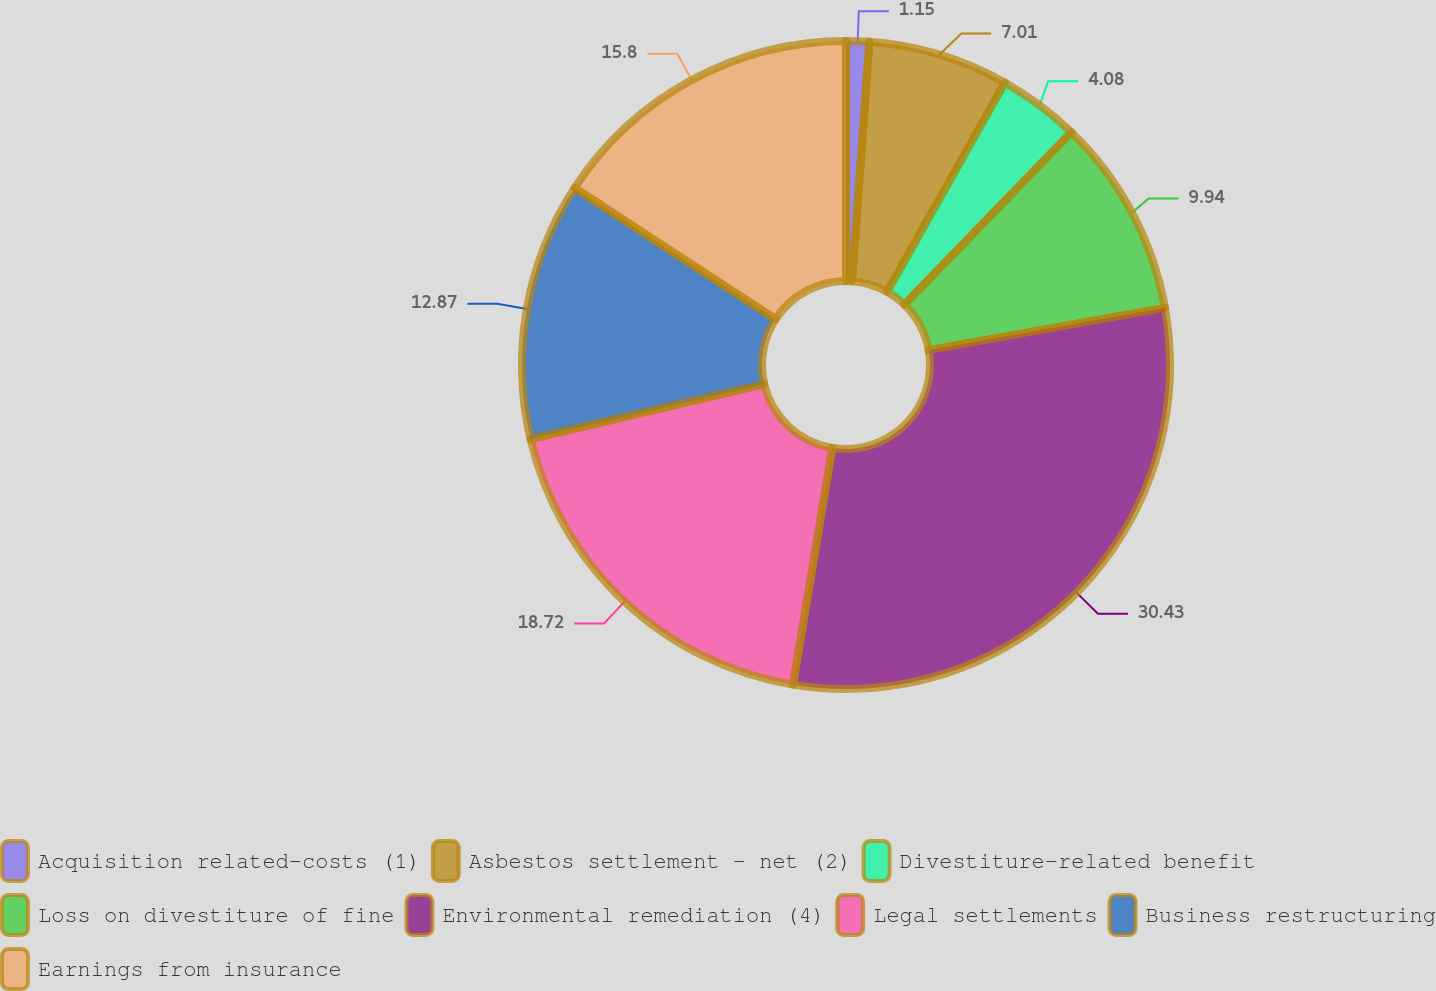<chart> <loc_0><loc_0><loc_500><loc_500><pie_chart><fcel>Acquisition related-costs (1)<fcel>Asbestos settlement - net (2)<fcel>Divestiture-related benefit<fcel>Loss on divestiture of fine<fcel>Environmental remediation (4)<fcel>Legal settlements<fcel>Business restructuring<fcel>Earnings from insurance<nl><fcel>1.15%<fcel>7.01%<fcel>4.08%<fcel>9.94%<fcel>30.44%<fcel>18.72%<fcel>12.87%<fcel>15.8%<nl></chart> 